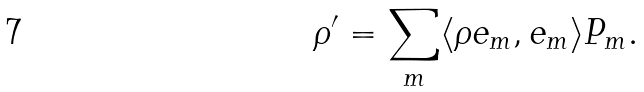<formula> <loc_0><loc_0><loc_500><loc_500>\rho ^ { \prime } = \sum _ { m } \langle \rho e _ { m } , e _ { m } \rangle P _ { m } .</formula> 